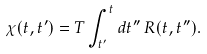<formula> <loc_0><loc_0><loc_500><loc_500>\chi ( t , t ^ { \prime } ) = T \int _ { t ^ { \prime } } ^ { t } d t ^ { \prime \prime } \, R ( t , t ^ { \prime \prime } ) .</formula> 